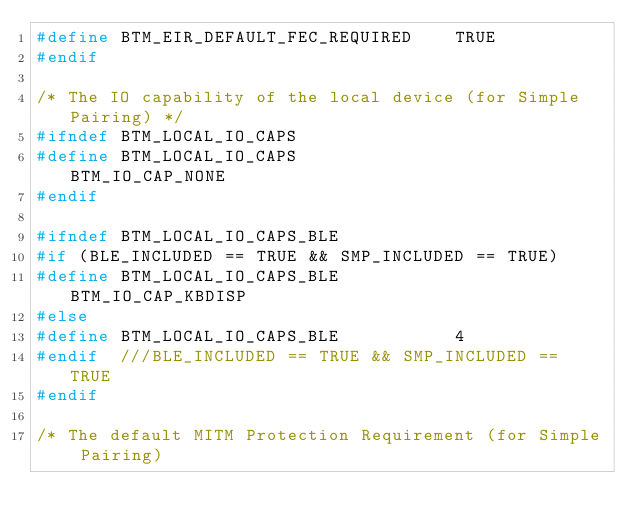Convert code to text. <code><loc_0><loc_0><loc_500><loc_500><_C_>#define BTM_EIR_DEFAULT_FEC_REQUIRED    TRUE
#endif

/* The IO capability of the local device (for Simple Pairing) */
#ifndef BTM_LOCAL_IO_CAPS
#define BTM_LOCAL_IO_CAPS               BTM_IO_CAP_NONE
#endif

#ifndef BTM_LOCAL_IO_CAPS_BLE
#if (BLE_INCLUDED == TRUE && SMP_INCLUDED == TRUE)
#define BTM_LOCAL_IO_CAPS_BLE           BTM_IO_CAP_KBDISP
#else
#define BTM_LOCAL_IO_CAPS_BLE           4
#endif  ///BLE_INCLUDED == TRUE && SMP_INCLUDED == TRUE
#endif

/* The default MITM Protection Requirement (for Simple Pairing)</code> 